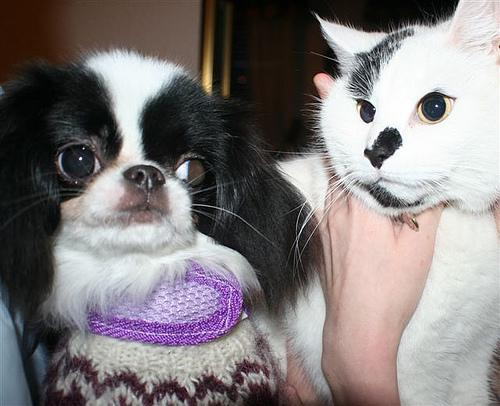How many cats are shown here? Please explain your reasoning. one. A cat and a dog are sitting together. 